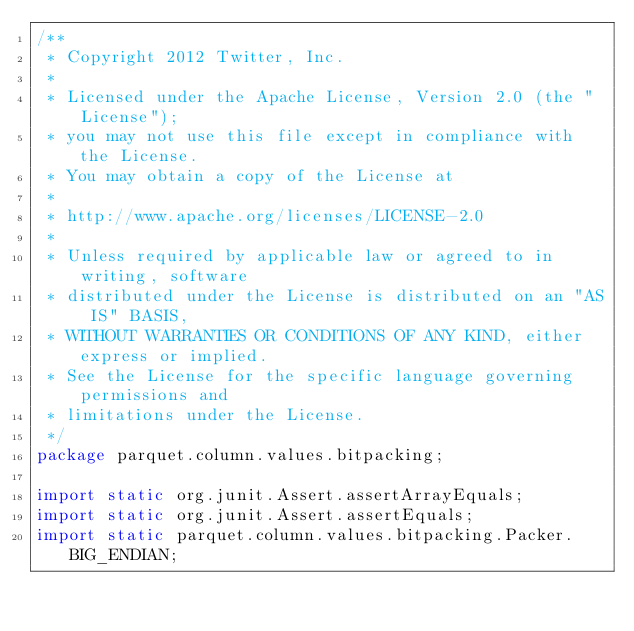<code> <loc_0><loc_0><loc_500><loc_500><_Java_>/**
 * Copyright 2012 Twitter, Inc.
 *
 * Licensed under the Apache License, Version 2.0 (the "License");
 * you may not use this file except in compliance with the License.
 * You may obtain a copy of the License at
 *
 * http://www.apache.org/licenses/LICENSE-2.0
 *
 * Unless required by applicable law or agreed to in writing, software
 * distributed under the License is distributed on an "AS IS" BASIS,
 * WITHOUT WARRANTIES OR CONDITIONS OF ANY KIND, either express or implied.
 * See the License for the specific language governing permissions and
 * limitations under the License.
 */
package parquet.column.values.bitpacking;

import static org.junit.Assert.assertArrayEquals;
import static org.junit.Assert.assertEquals;
import static parquet.column.values.bitpacking.Packer.BIG_ENDIAN;
</code> 